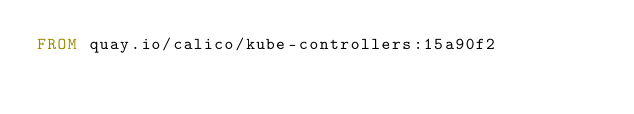<code> <loc_0><loc_0><loc_500><loc_500><_Dockerfile_>FROM quay.io/calico/kube-controllers:15a90f2
</code> 